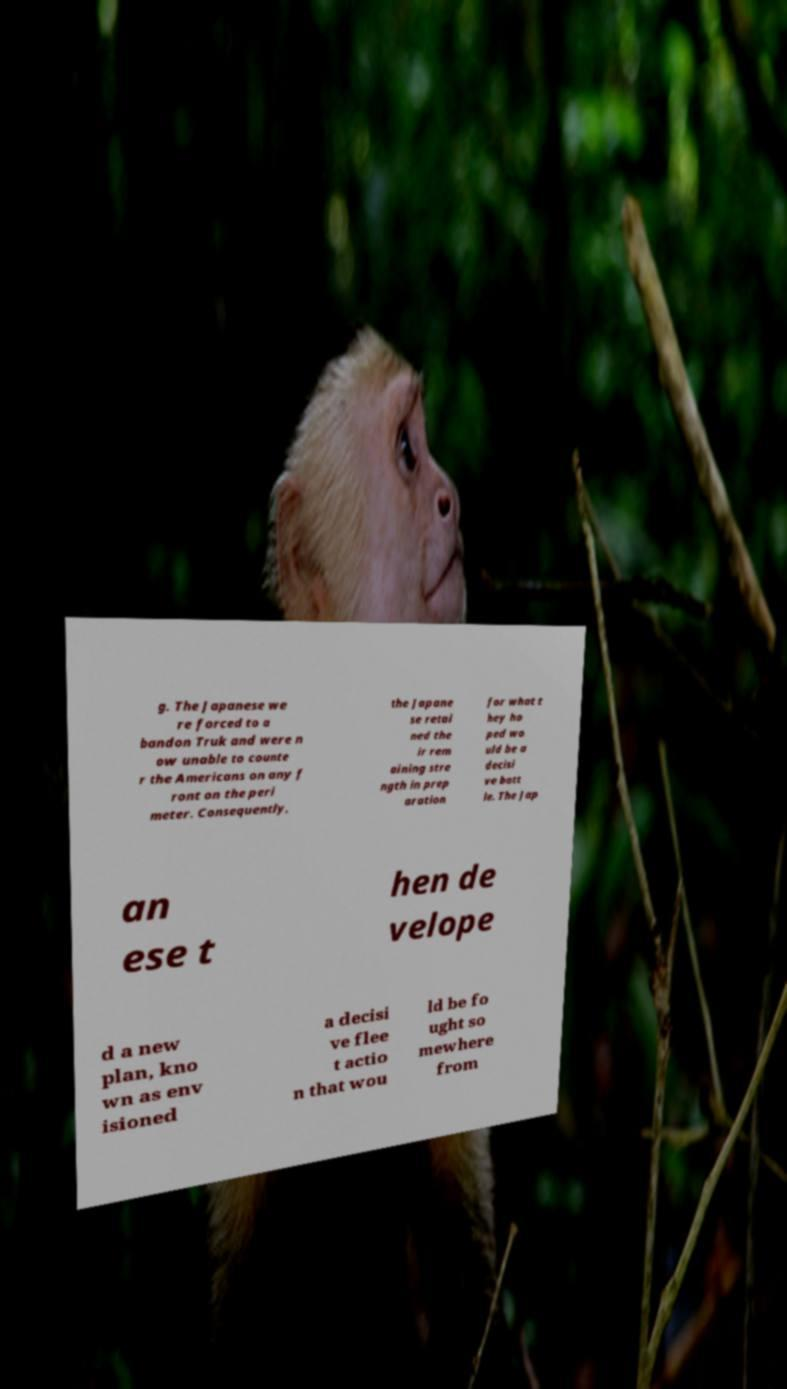Please identify and transcribe the text found in this image. g. The Japanese we re forced to a bandon Truk and were n ow unable to counte r the Americans on any f ront on the peri meter. Consequently, the Japane se retai ned the ir rem aining stre ngth in prep aration for what t hey ho ped wo uld be a decisi ve batt le. The Jap an ese t hen de velope d a new plan, kno wn as env isioned a decisi ve flee t actio n that wou ld be fo ught so mewhere from 